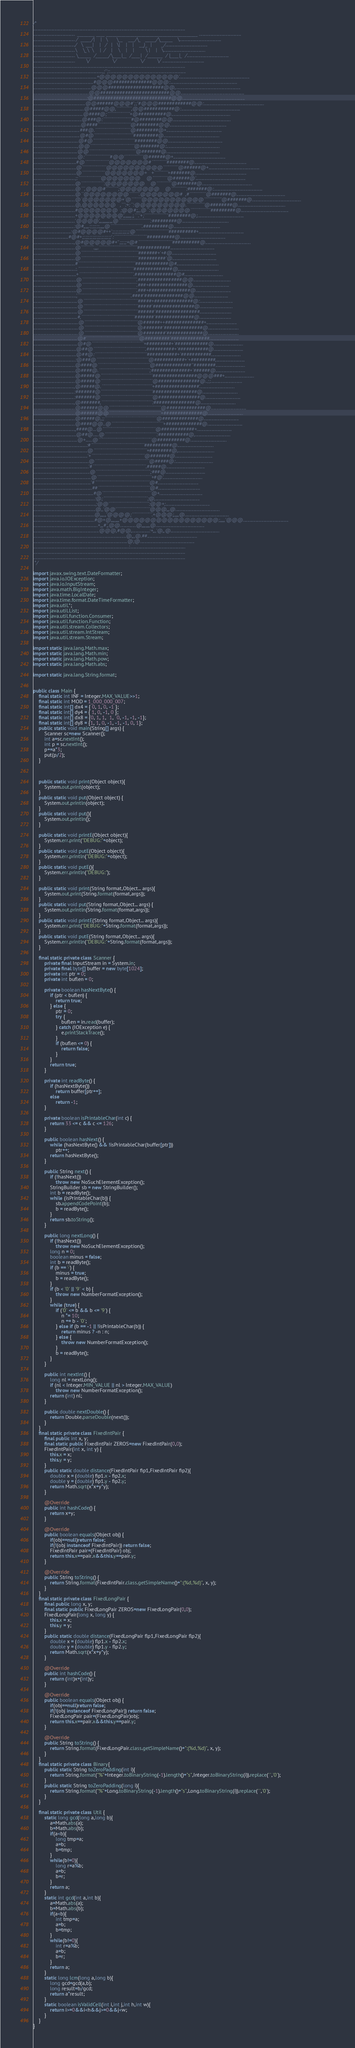Convert code to text. <code><loc_0><loc_0><loc_500><loc_500><_Java_>/*
......................................................................................................................................
.....................................  ________ ____ __________________________________________ .....................................
..................................... /  _____/|    |   \      \__    ___/\_   _____/\______   \.....................................
...................................../   \  ___|    |   /   |   \|    |    |    __)_  |       _/.....................................
.....................................\    \_\  \    |  /    |    \    |    |        \ |    |   \.....................................
..................................... \______  /______/\____|__  /____|   /_______  / |____|_  /.....................................
.....................................        \/                \/                 \/         \/ .....................................
......................................................................................................................................
.............................................................,;'';:...................................................................
........................................................+@@@@@@@@@@@@@@'..............................................................
.....................................................#@@@##############@@@:...........................................................
...................................................@@@####################@@,.........................................................
.................................................@@#########################@@........................................................
...............................................:@############################@@.......................................................
..............................................@@######@@@#';;'#@@@############@@:.....................................................
.............................................@#####@@,````````````,@@###########@:....................................................
............................................@####@;``````````````````+@##########@....................................................
...........................................@###@:``````````````````````#@########@@...................................................
..........................................@####``````````````````````````@########@@..................................................
.........................................###@.````````````````````````````@########@+.................................................
.........................................@#@```````````````````````````````#########@.................................................
........................................@#@`````````````````````````````````########@@................................................
.......................................,@@```````````````````````````````````@#######@:...............................................
.......................................@@`````````````````````````````````````@#######@...............................................
.......................................@:````````````````````#@@'``````````````@######@+..............................................
......................................#@```````````````````@@@@@@@#````````````########@..............................................
......................................@```````````````````@@@@@@@@@@````````````@######@+.............................................
......................................@``````````````````@@@@@@@+   +```````````+#######@.............................................
.....................................;:``````````````````@@@@@@@    @````````````@######@'............................................
.....................................@``````````````````:@@@@@@@    @````````````@#######@............................................
.....................................@```,@@@#``````````;@@@@@@@    @````````````:#######@:...........................................
.....................................@``@@@@@@@@````````.@@@@@@@#  ,#`````````````@#######@...........................................
.....................................@`@@@@@@@+'@````````@@@@@@@@@@@``````````````@#######@...........................................
.....................................@,@@@@@@   ,```:+:``:@@@@@@@@@.``````````````@########@..........................................
.....................................#@@@@@@@  ;@@#;,,,@``:@@@@@@@````````````````#########@..........................................
.....................................+@@@@@@@@',,,,,,,,;,```.'+;``````````````````'########@;.........................................
.....................................'@@@@',,,,,,,,,,,,,@`````````````````````````:#########@.........................................
....................................:@#,,,,,:;;;;;:,,,,,@`````````````````````````.#########@.........................................
.................................:@#@@@@#++';;;;;;;;;;;;@``````````````````````````##########+........................................
...............................#@#+;;;;;;;;;;;;;;;;;;;;':``````````````````````````##########@........................................
....................................,@#@@@@@#+'';;;;;+@#```````````````````````````##########@........................................
.....................................@``````````.,,,.``````````````````````````````############.......................................
.....................................@`````````````````````````````````````````````#######+'+#@.......................................
.....................................@`````````````````````````````````````````````##########'@.......................................
.....................................#`````````````````````````````````````````````############@#.....................................
.....................................:.````````````````````````````````````````````##############@,...................................
......................................+```````````````````````````````````````````.###############@#..................................
......................................@```````````````````````````````````````````.################@@.................................
......................................@```````````````````````````````````````````.###+##############@................................
......................................@```````````````````````````````````````````.###+###############@...............................
......................................',``````````````````````````````````````````.####'##############@@..............................
.......................................@```````````````````````````````````````````#####+##############@:.............................
.......................................@```````````````````````````````````````````#####'###############@.............................
.......................................@```````````````````````````````````````````######'################............................
.......................................#,``````````````````````````````````````````#######'##############@............................
........................................@``````````````````````````````````````````@######++##############+...........................
........................................@``````````````````````````````````````````@#######'##############@...........................
........................................@``````````````````````````````````````````@########'#############@...........................
.......................................@#'`````````````````````````````````````````@#########'##############..........................
.......................................@#@`````````````````````````````````````````+#########+'############@..........................
......................................@##@`````````````````````````````````````````.##########+'###########@..........................
......................................@##@:`````````````````````````````````````````###########+'###########..........................
.....................................:@###@`````````````````````````````````````````@###########+'+#########,.........................
.....................................@####@`````````````````````````````````````````@#############''########..........................
.....................................@####@.````````````````````````````````````````;##############+'######@..........................
.....................................@#####@`````````````````````````````````````````################@@@###+..........................
.....................................@#####@`````````````````````````````````````````@###############@..;;............................
....................................,@#####@.````````````````````````````````````````+################'...............................
....................................:#######@`````````````````````````````````````````################@...............................
....................................:#######@`````````````````````````````````````````@###############@...............................
....................................,@#######,````````````````````````````````````````:###############@...............................
.....................................@######@@`````````````````````````````````````````@##############@...............................
.....................................@######@@`````````````````````````````````````````+##############@...............................
.....................................@#####@,;;`````````````````````````````````````````@#############@...............................
.....................................@####@@..@`````````````````````````````````````````+#############@...............................
.....................................,####@...@``````````````````````````````````````````@############+...............................
......................................@##@.....@`````````````````````````````````````````:###########@,...............................
.......................................@+......@``````````````````````````````````````````@##########@................................
...............................................:#``````````````````````````````````````````##########@................................
................................................@``````````````````````````````````````````+########@,................................
................................................'+``````````````````````````````````````````@#######@.................................
.................................................@```````````````````````````````````````````@#####@:.................................
.................................................'#``````````````````````````````````````````.#####@..................................
..................................................@```````````````````````````````````````````;###@...................................
...................................................@```````````````````````````````````````````+#@'...................................
...................................................'#```````````````````````````````````````````@#....................................
....................................................##`````````````````````````````````````````@#.....................................
.....................................................#@```````````````````````````````````````@+......................................
......................................................:@;```````````````````````````````````;@,.......................................
.......................................................;@@'```````````````````````````````:@@+;.......................................
.......................................................@,,'@@'``````````````````````````@@@,,,@.......................................
......................................................@,,,,,,'@@@@;````````````````.+@@@;,,,,,@.......................................
......................................................#@+@,,,,,,,,+@@@@@@@@@@@@@@@@@;,,,,,'@@@........................................
.........................................................+,,,#',,@@..............@,,,,,,,,@...........................................
..........................................................@@@,#@@,...............:+,,,'@,,@...........................................
..................................................................................@,,,@.##............................................
...................................................................................@;@................................................
....................................................................................:.................................................
......................................................................................................................................
......................................................................................................................................
 */

import javax.swing.text.DateFormatter;
import java.io.IOException;
import java.io.InputStream;
import java.math.BigInteger;
import java.time.LocalDate;
import java.time.format.DateTimeFormatter;
import java.util.*;
import java.util.List;
import java.util.function.Consumer;
import java.util.function.Function;
import java.util.stream.Collectors;
import java.util.stream.IntStream;
import java.util.stream.Stream;

import static java.lang.Math.max;
import static java.lang.Math.min;
import static java.lang.Math.pow;
import static java.lang.Math.abs;

import static java.lang.String.format;


public class Main {
    final static int INF = Integer.MAX_VALUE>>1;
    final static int MOD = 1_000_000_007;
    final static int[] dx4 = { 0, 1, 0, -1 };
    final static int[] dy4 = { 1, 0, -1, 0 };
    final static int[] dx8 = {0, 1, 1,  1,  0, -1, -1, -1};
    final static int[] dy8 = {1, 1, 0, -1, -1, -1, 0, 1};
    public static void main(String[] args) {
        Scanner sc=new Scanner();
        int a=sc.nextInt();
        int p = sc.nextInt();
        p+=a*3;
        put(p/2);
    }



    public static void print(Object object){
        System.out.print(object);
    }
    public static void put(Object object) {
        System.out.println(object);
    }
    public static void put(){
        System.out.println();
    }

    public static void printE(Object object){
        System.err.print("DEBUG:"+object);
    }
    public static void putE(Object object){
        System.err.println("DEBUG:"+object);
    }
    public static void putE(){
        System.err.println("DEBUG:");
    }

    public static void print(String format,Object... args){
        System.out.print(String.format(format,args));
    }
    public static void put(String format,Object... args) {
        System.out.println(String.format(format,args));
    }
    public static void printE(String format,Object... args){
        System.err.print("DEBUG:"+String.format(format,args));
    }
    public static void putE(String format,Object... args){
        System.err.println("DEBUG:"+String.format(format,args));
    }

    final static private class Scanner {
        private final InputStream in = System.in;
        private final byte[] buffer = new byte[1024];
        private int ptr = 0;
        private int buflen = 0;

        private boolean hasNextByte() {
            if (ptr < buflen) {
                return true;
            } else {
                ptr = 0;
                try {
                    buflen = in.read(buffer);
                } catch (IOException e) {
                    e.printStackTrace();
                }
                if (buflen <= 0) {
                    return false;
                }
            }
            return true;
        }

        private int readByte() {
            if (hasNextByte())
                return buffer[ptr++];
            else
                return -1;
        }

        private boolean isPrintableChar(int c) {
            return 33 <= c && c <= 126;
        }

        public boolean hasNext() {
            while (hasNextByte() && !isPrintableChar(buffer[ptr]))
                ptr++;
            return hasNextByte();
        }

        public String next() {
            if (!hasNext())
                throw new NoSuchElementException();
            StringBuilder sb = new StringBuilder();
            int b = readByte();
            while (isPrintableChar(b)) {
                sb.appendCodePoint(b);
                b = readByte();
            }
            return sb.toString();
        }

        public long nextLong() {
            if (!hasNext())
                throw new NoSuchElementException();
            long n = 0;
            boolean minus = false;
            int b = readByte();
            if (b == '-') {
                minus = true;
                b = readByte();
            }
            if (b < '0' || '9' < b) {
                throw new NumberFormatException();
            }
            while (true) {
                if ('0' <= b && b <= '9') {
                    n *= 10;
                    n += b - '0';
                } else if (b == -1 || !isPrintableChar(b)) {
                    return minus ? -n : n;
                } else {
                    throw new NumberFormatException();
                }
                b = readByte();
            }
        }

        public int nextInt() {
            long nl = nextLong();
            if (nl < Integer.MIN_VALUE || nl > Integer.MAX_VALUE)
                throw new NumberFormatException();
            return (int) nl;
        }

        public double nextDouble() {
            return Double.parseDouble(next());
        }
    }
    final static private class FixedIntPair {
        final public int x, y;
        final static public FixedIntPair ZEROS=new FixedIntPair(0,0);
        FixedIntPair(int x, int y) {
            this.x = x;
            this.y = y;
        }
        public static double distance(FixedIntPair fip1,FixedIntPair fip2){
            double x = (double) fip1.x - fip2.x;
            double y = (double) fip1.y - fip2.y;
            return Math.sqrt(x*x+y*y);
        }

        @Override
        public int hashCode() {
            return x+y;
        }

        @Override
        public boolean equals(Object obj) {
            if(obj==null)return false;
            if(!(obj instanceof FixedIntPair)) return false;
            FixedIntPair pair=(FixedIntPair) obj;
            return this.x==pair.x&&this.y==pair.y;
        }

        @Override
        public String toString() {
            return String.format(FixedIntPair.class.getSimpleName()+":(%d,%d)", x, y);
        }
    }
    final static private class FixedLongPair {
        final public long x, y;
        final static public FixedLongPair ZEROS=new FixedLongPair(0,0);
        FixedLongPair(long x, long y) {
            this.x = x;
            this.y = y;
        }
        public static double distance(FixedLongPair flp1,FixedLongPair flp2){
            double x = (double) flp1.x - flp2.x;
            double y = (double) flp1.y - flp2.y;
            return Math.sqrt(x*x+y*y);
        }

        @Override
        public int hashCode() {
            return (int)x+(int)y;
        }

        @Override
        public boolean equals(Object obj) {
            if(obj==null)return false;
            if(!(obj instanceof FixedLongPair)) return false;
            FixedLongPair pair=(FixedLongPair)obj;
            return this.x==pair.x&&this.y==pair.y;
        }

        @Override
        public String toString() {
            return String.format(FixedLongPair.class.getSimpleName()+":(%d,%d)", x, y);
        }
    }
    final static private class Binary{
        public static String toZeroPadding(int i){
            return String.format("%"+Integer.toBinaryString(-1).length()+"s",Integer.toBinaryString(i)).replace(' ','0');
        }
        public static String toZeroPadding(long i){
            return String.format("%"+Long.toBinaryString(-1).length()+"s",Long.toBinaryString(i)).replace(' ','0');
        }
    }

    final static private class Util {
        static long gcd(long a,long b){
            a=Math.abs(a);
            b=Math.abs(b);
            if(a<b){
                long tmp=a;
                a=b;
                b=tmp;
            }
            while(b!=0){
                long r=a%b;
                a=b;
                b=r;
            }
            return a;
        }
        static int gcd(int a,int b){
            a=Math.abs(a);
            b=Math.abs(b);
            if(a<b){
                int tmp=a;
                a=b;
                b=tmp;
            }
            while(b!=0){
                int r=a%b;
                a=b;
                b=r;
            }
            return a;
        }
        static long lcm(long a,long b){
            long gcd=gcd(a,b);
            long result=b/gcd;
            return a*result;
        }
        static boolean isValidCell(int i,int j,int h,int w){
            return i>=0&&i<h&&j>=0&&j<w;
        }
    }
}
</code> 